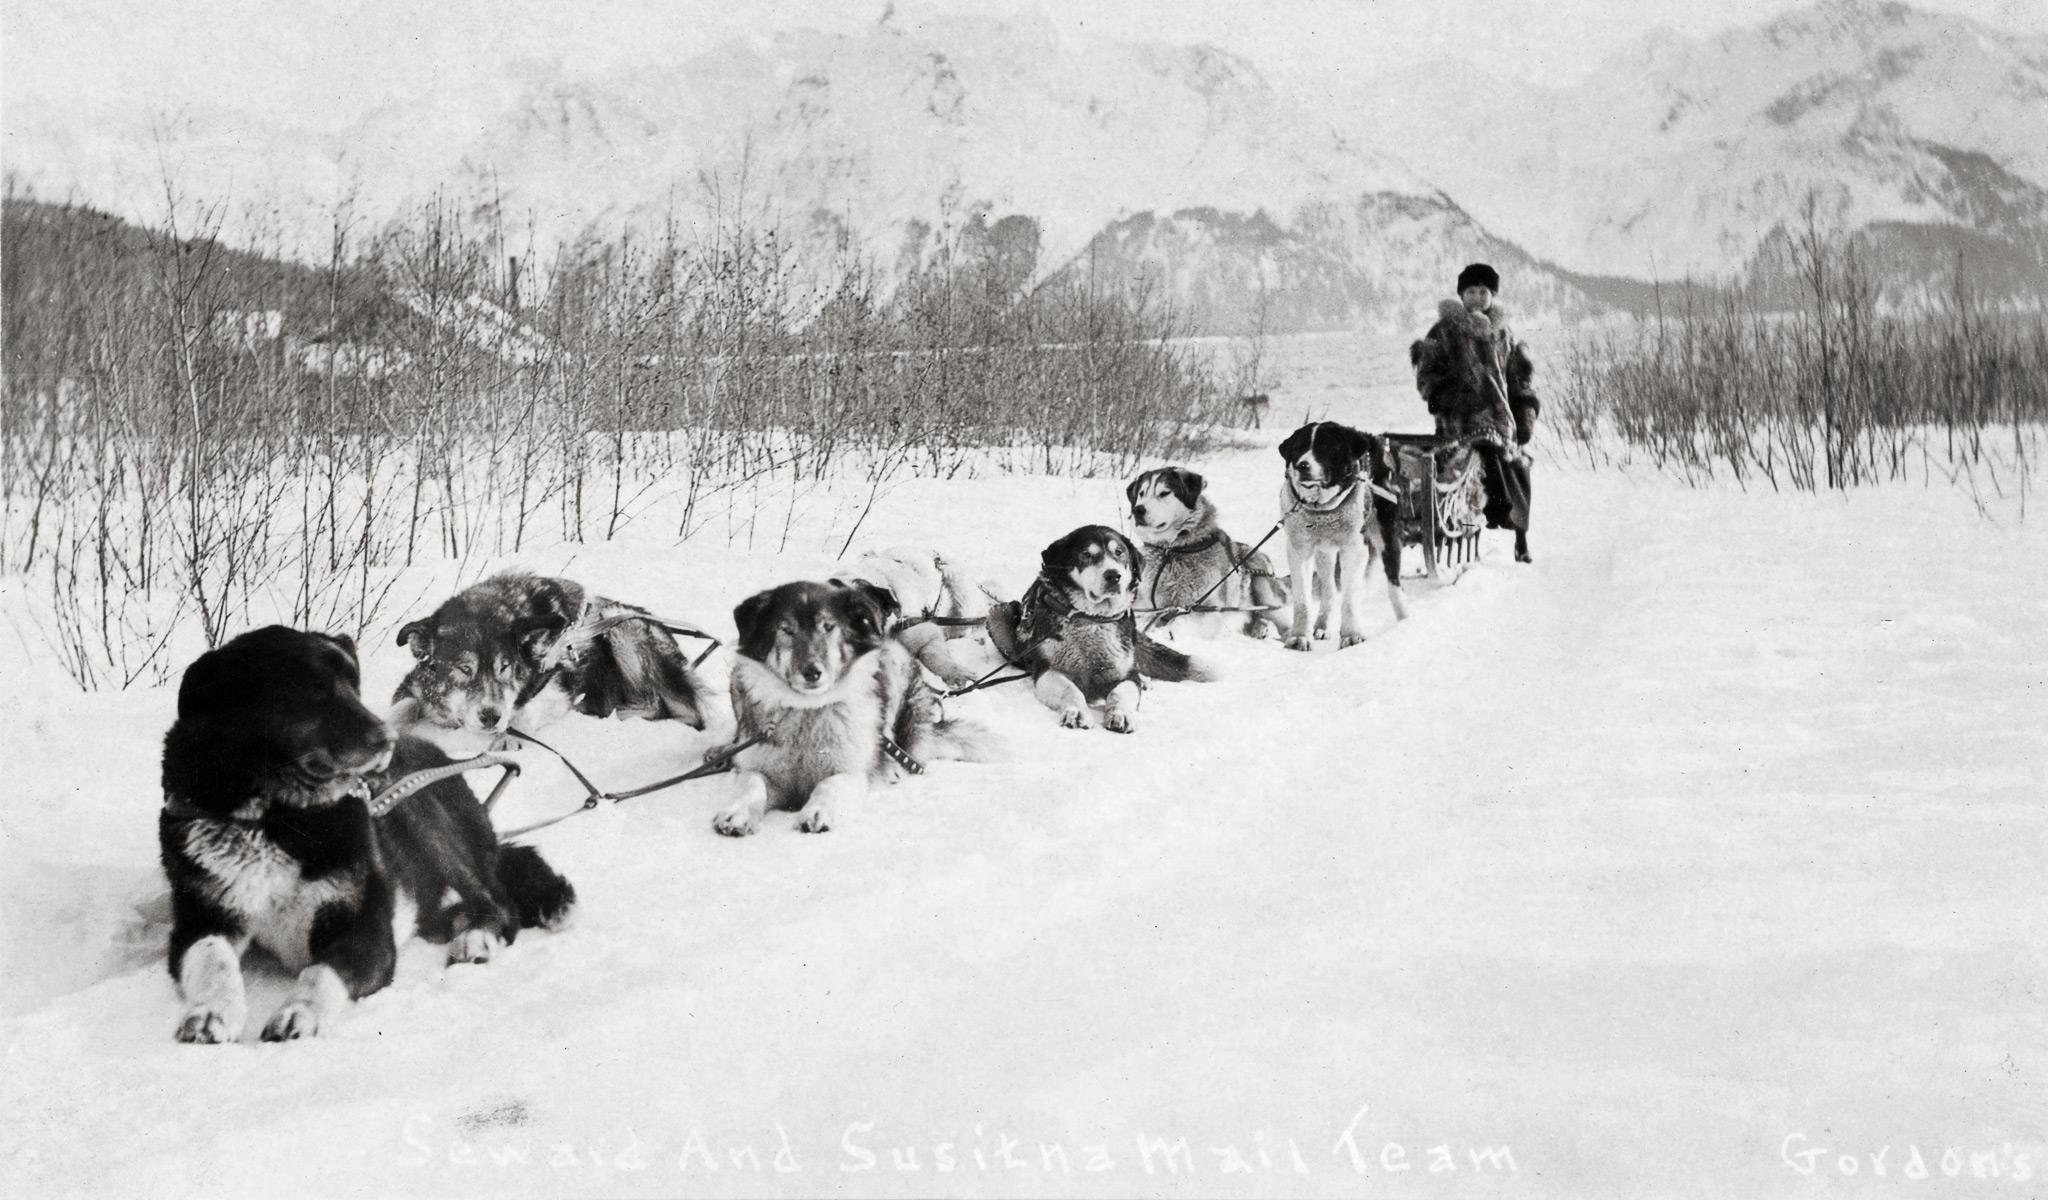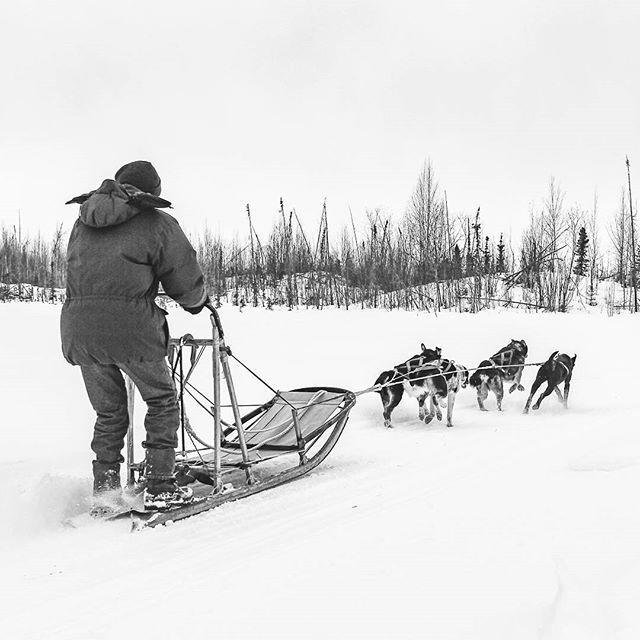The first image is the image on the left, the second image is the image on the right. Considering the images on both sides, is "One of the images shows flat terrain with no trees behind the sled dogs." valid? Answer yes or no. No. The first image is the image on the left, the second image is the image on the right. Given the left and right images, does the statement "The lead dog of a sled team aimed leftward is reclining on the snow with both front paws extended and is gazing to the side." hold true? Answer yes or no. Yes. 